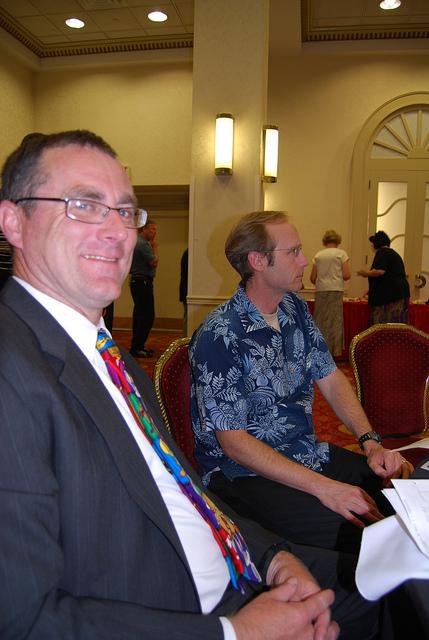Where are the men sitting in the chairs?
Be succinct. In room. What kind of room are the people in?
Give a very brief answer. Conference. Do the men match in clothing styles?
Concise answer only. No. 